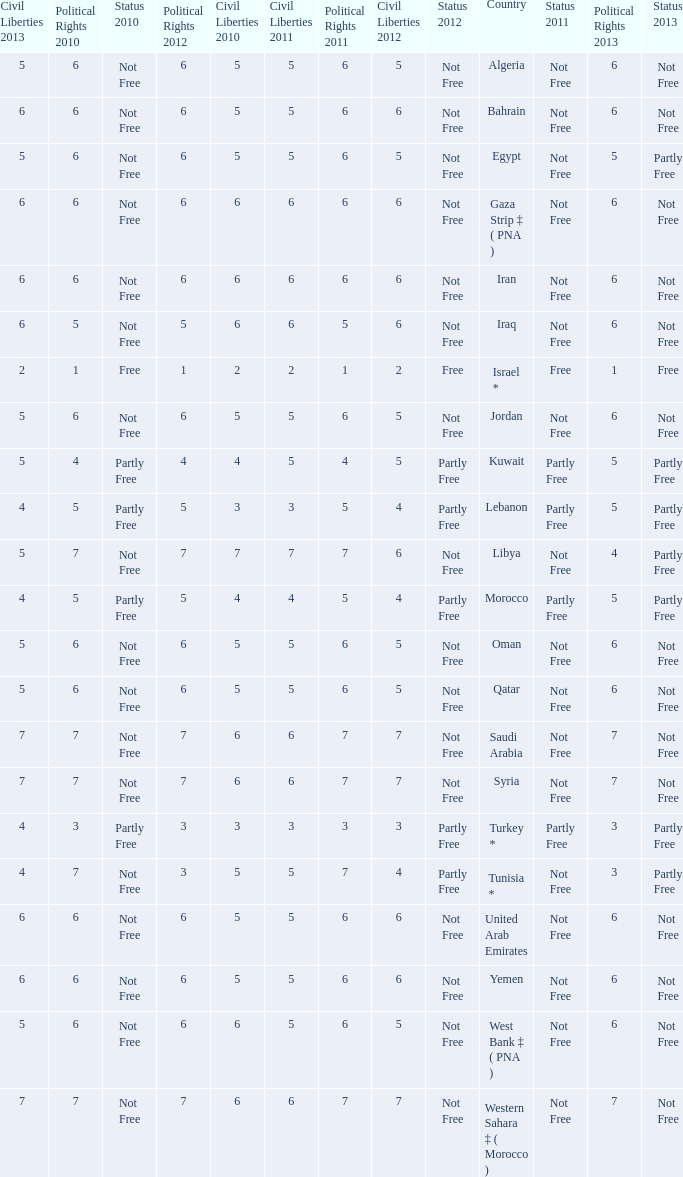How many civil liberties 2013 values are associated with a 2010 political rights value of 6, civil liberties 2012 values over 5, and political rights 2011 under 6? 0.0. 